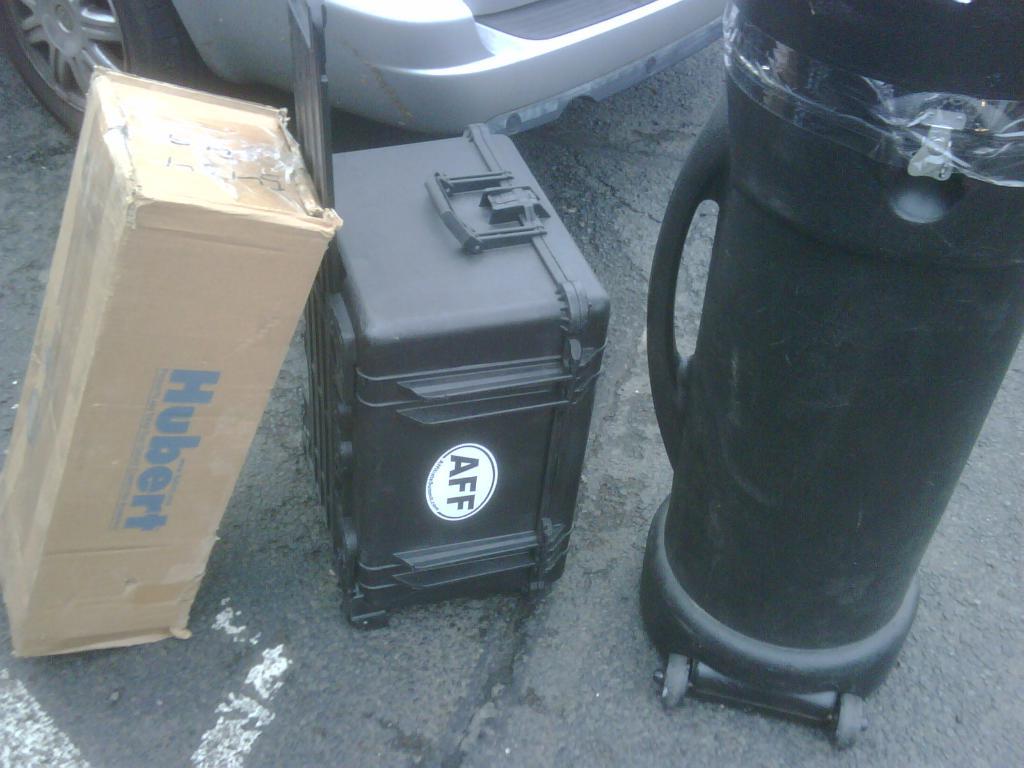What is the name on the box?
Offer a very short reply. Hubert. What company is the product from?
Offer a very short reply. Hubert. 